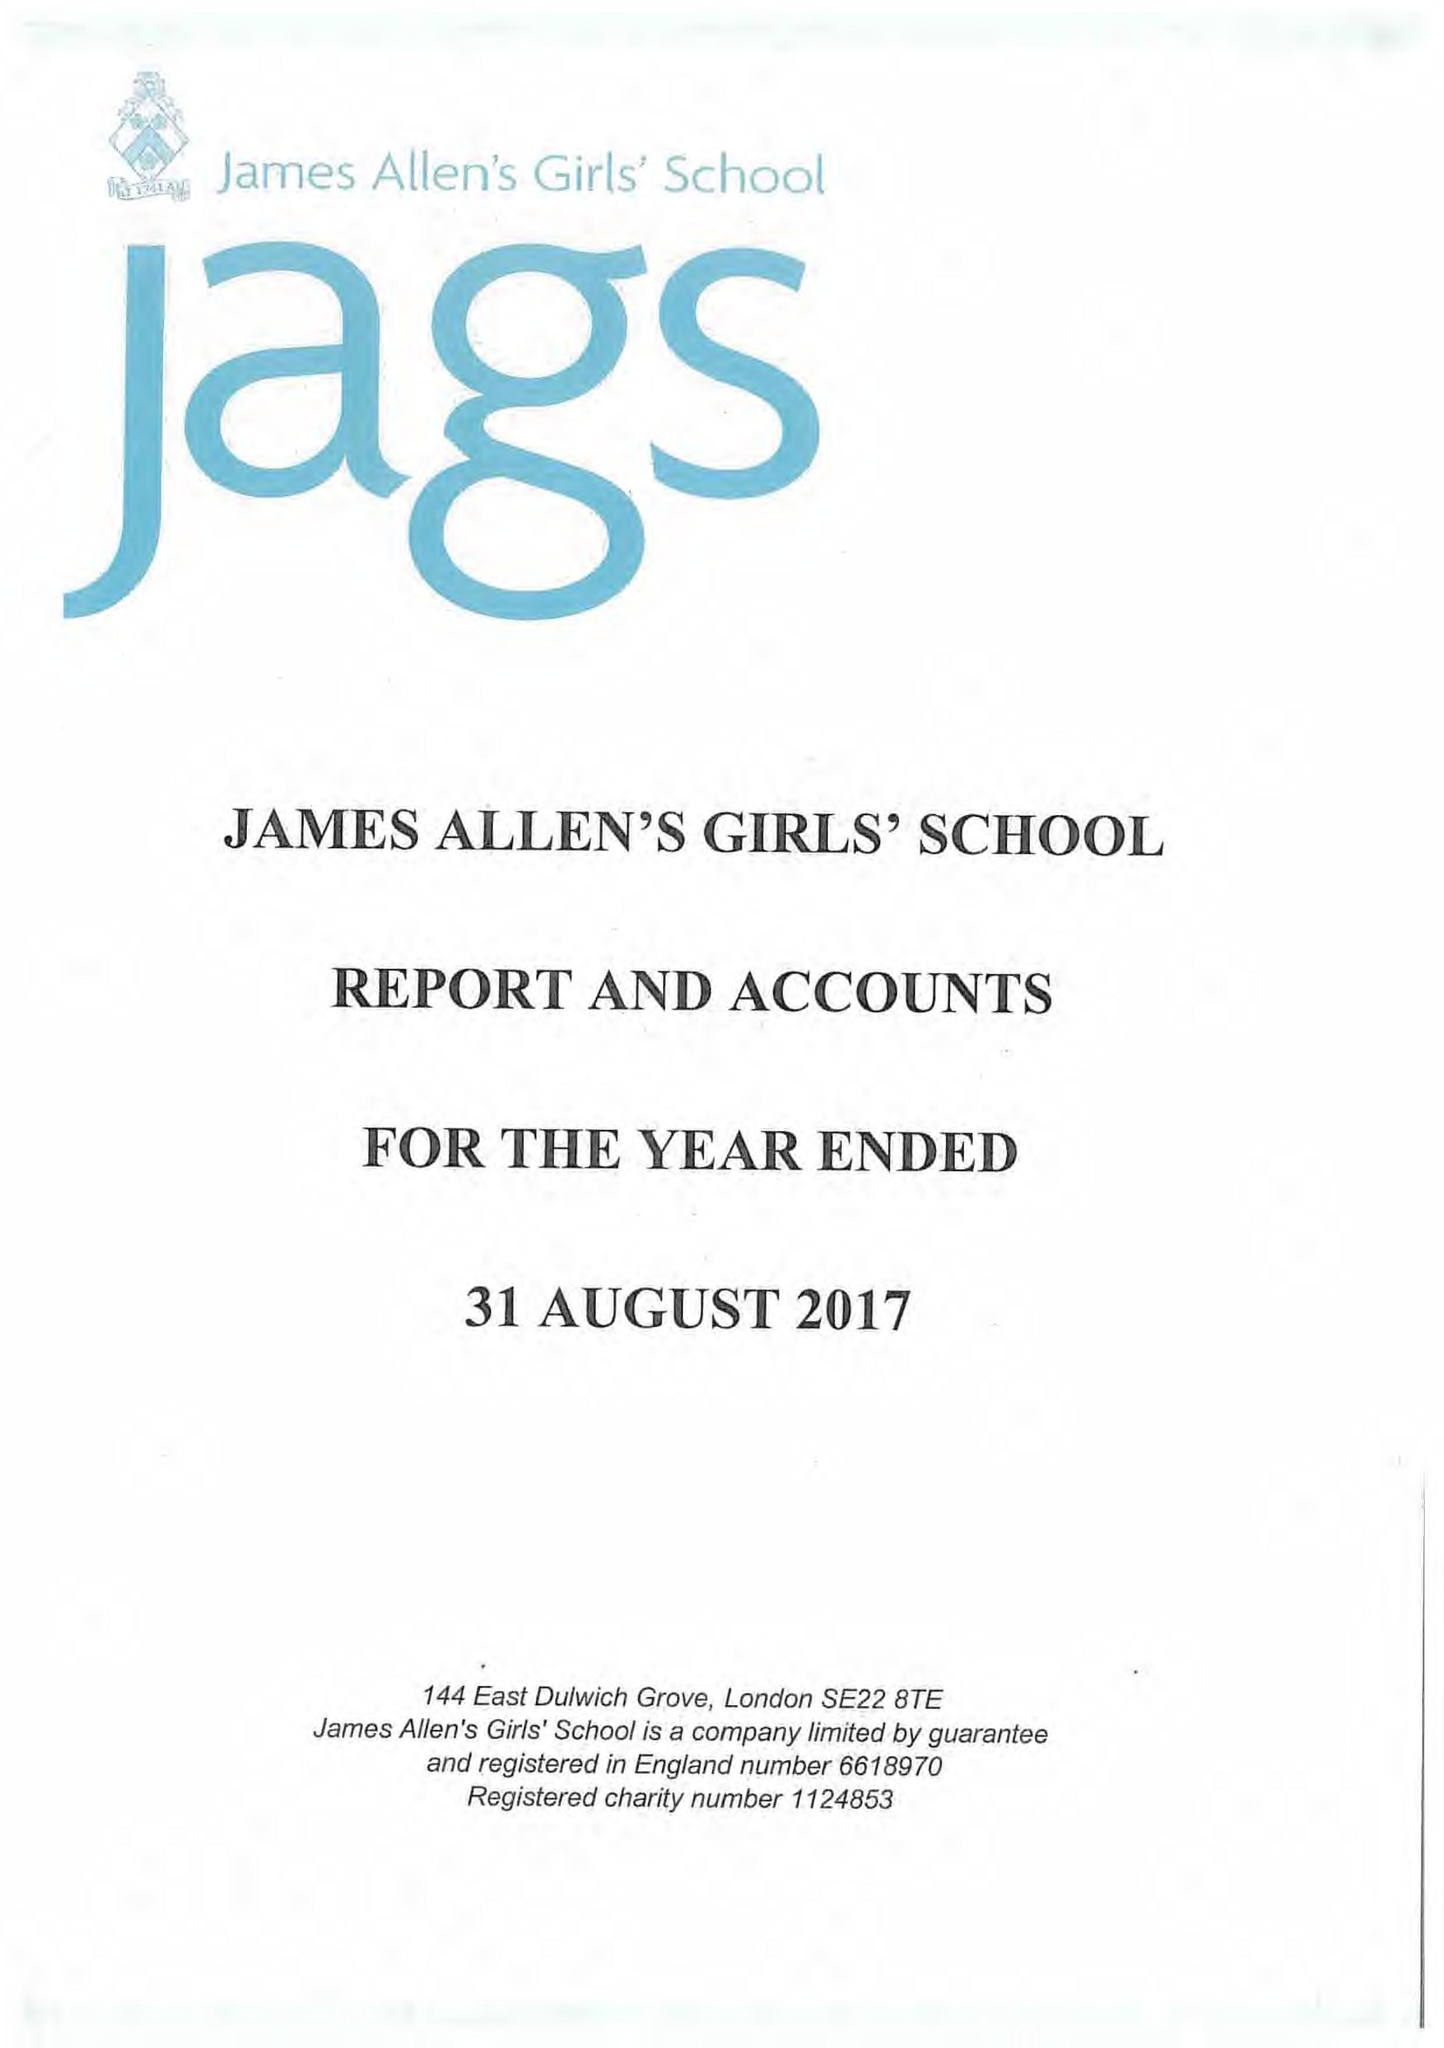What is the value for the address__postcode?
Answer the question using a single word or phrase. SE22 8TE 